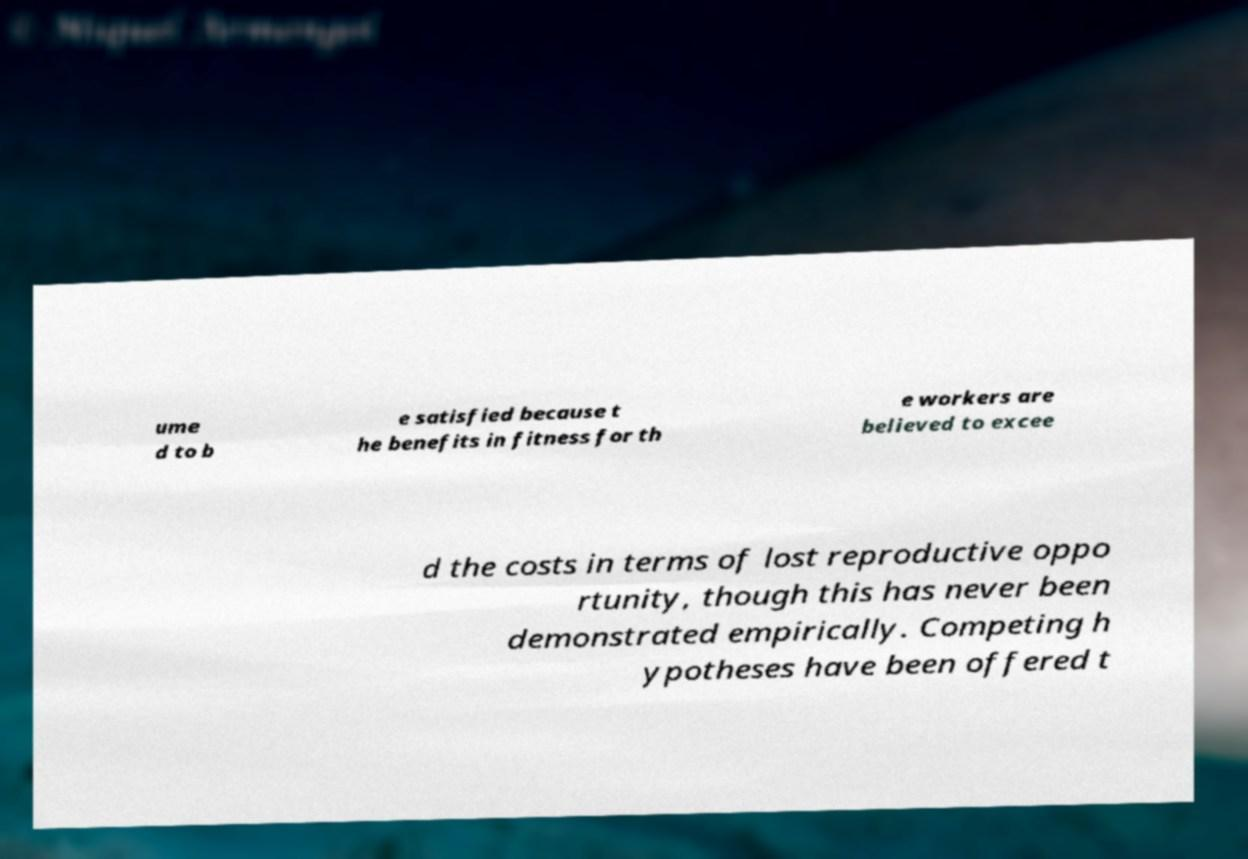Could you assist in decoding the text presented in this image and type it out clearly? ume d to b e satisfied because t he benefits in fitness for th e workers are believed to excee d the costs in terms of lost reproductive oppo rtunity, though this has never been demonstrated empirically. Competing h ypotheses have been offered t 